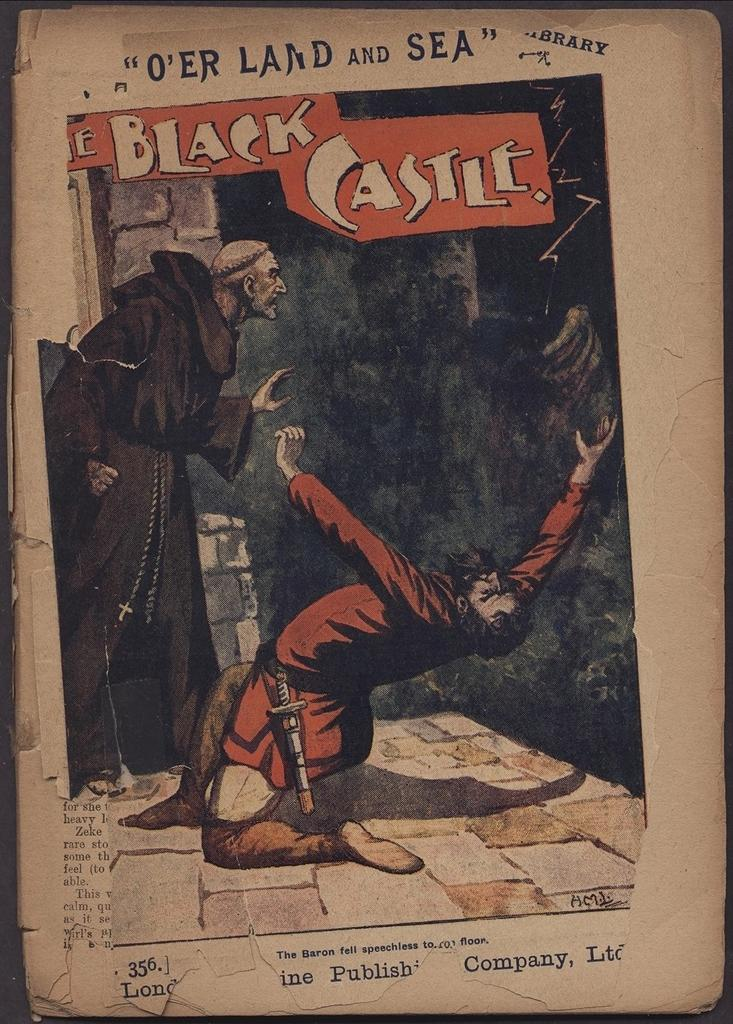<image>
Relay a brief, clear account of the picture shown. A weathered copy of a comic book titled The Black Castle. 